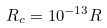<formula> <loc_0><loc_0><loc_500><loc_500>R _ { c } = 1 0 ^ { - 1 3 } R</formula> 